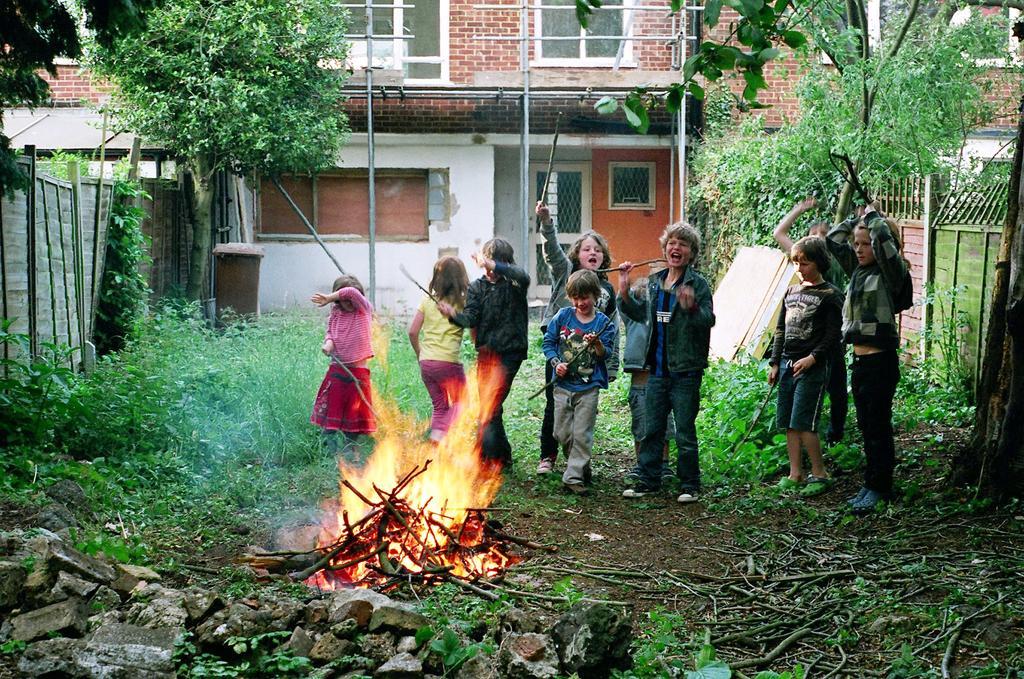Describe this image in one or two sentences. In the center of the image there is a campfire. There are children standing. At the bottom of the image there is grass. There are stones. In the background of the image there is house. There are trees. 